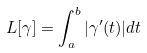Convert formula to latex. <formula><loc_0><loc_0><loc_500><loc_500>L [ \gamma ] = \int _ { a } ^ { b } | \gamma ^ { \prime } ( t ) | d t</formula> 